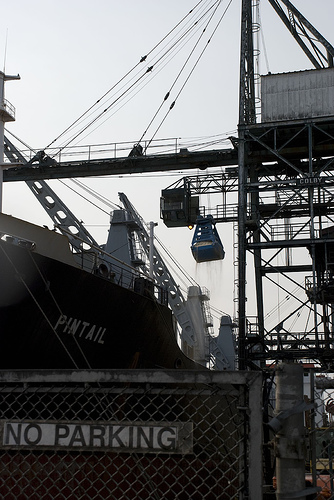<image>
Is the boat behind the fence? Yes. From this viewpoint, the boat is positioned behind the fence, with the fence partially or fully occluding the boat. 